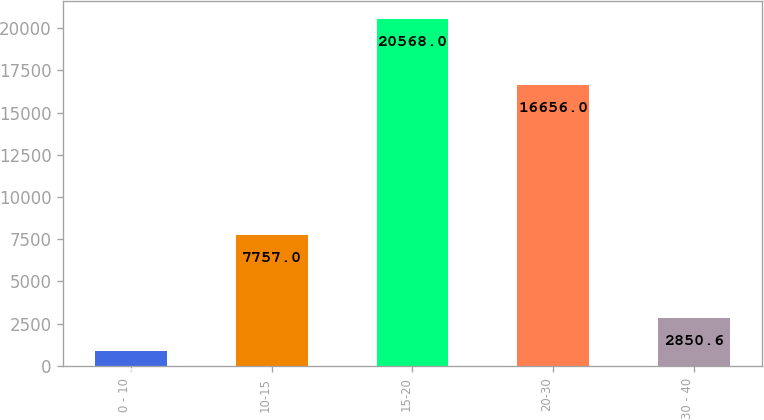<chart> <loc_0><loc_0><loc_500><loc_500><bar_chart><fcel>0 - 10<fcel>10-15<fcel>15-20<fcel>20-30<fcel>30 - 40<nl><fcel>882<fcel>7757<fcel>20568<fcel>16656<fcel>2850.6<nl></chart> 